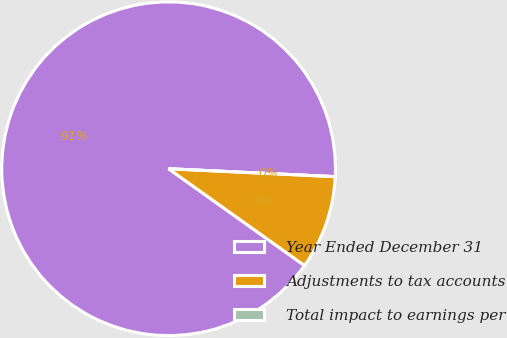Convert chart. <chart><loc_0><loc_0><loc_500><loc_500><pie_chart><fcel>Year Ended December 31<fcel>Adjustments to tax accounts<fcel>Total impact to earnings per<nl><fcel>90.91%<fcel>9.09%<fcel>0.0%<nl></chart> 